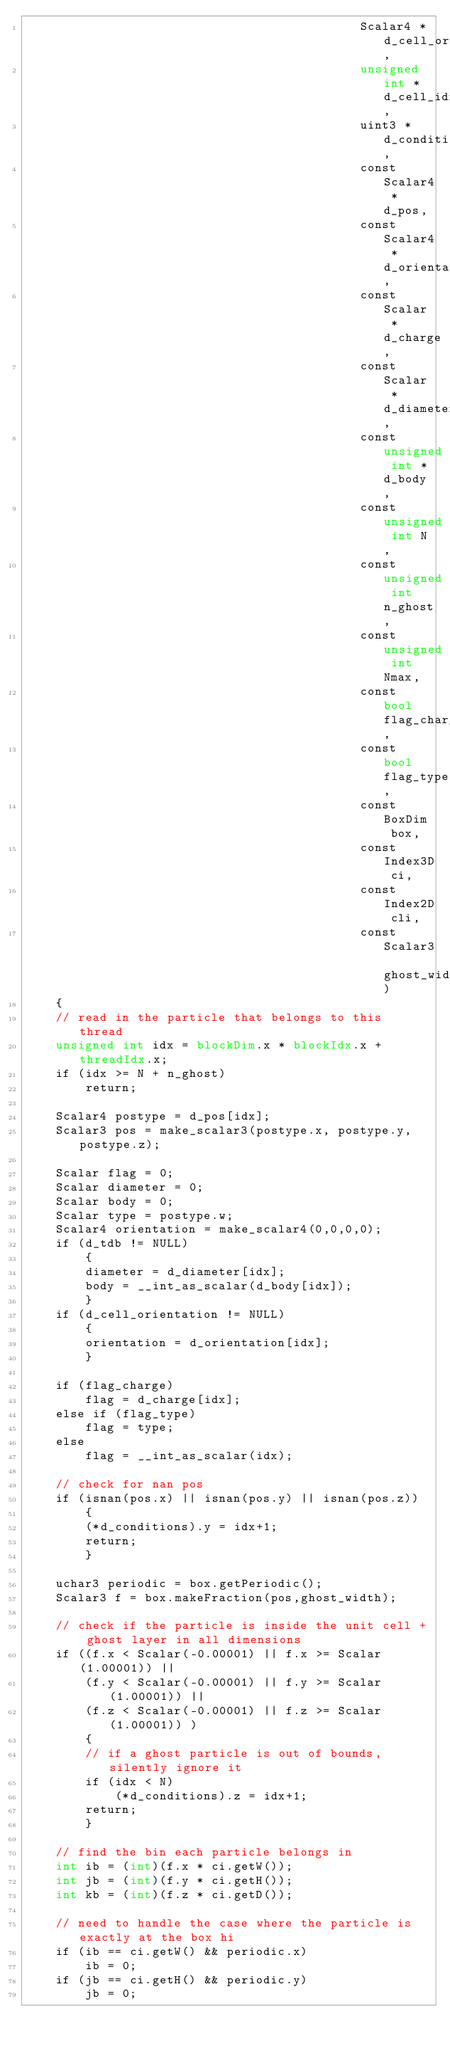Convert code to text. <code><loc_0><loc_0><loc_500><loc_500><_Cuda_>                                             Scalar4 *d_cell_orientation,
                                             unsigned int *d_cell_idx,
                                             uint3 *d_conditions,
                                             const Scalar4 *d_pos,
                                             const Scalar4 *d_orientation,
                                             const Scalar *d_charge,
                                             const Scalar *d_diameter,
                                             const unsigned int *d_body,
                                             const unsigned int N,
                                             const unsigned int n_ghost,
                                             const unsigned int Nmax,
                                             const bool flag_charge,
                                             const bool flag_type,
                                             const BoxDim box,
                                             const Index3D ci,
                                             const Index2D cli,
                                             const Scalar3 ghost_width)
    {
    // read in the particle that belongs to this thread
    unsigned int idx = blockDim.x * blockIdx.x + threadIdx.x;
    if (idx >= N + n_ghost)
        return;

    Scalar4 postype = d_pos[idx];
    Scalar3 pos = make_scalar3(postype.x, postype.y, postype.z);

    Scalar flag = 0;
    Scalar diameter = 0;
    Scalar body = 0;
    Scalar type = postype.w;
    Scalar4 orientation = make_scalar4(0,0,0,0);
    if (d_tdb != NULL)
        {
        diameter = d_diameter[idx];
        body = __int_as_scalar(d_body[idx]);
        }
    if (d_cell_orientation != NULL)
        {
        orientation = d_orientation[idx];
        }

    if (flag_charge)
        flag = d_charge[idx];
    else if (flag_type)
        flag = type;
    else
        flag = __int_as_scalar(idx);

    // check for nan pos
    if (isnan(pos.x) || isnan(pos.y) || isnan(pos.z))
        {
        (*d_conditions).y = idx+1;
        return;
        }

    uchar3 periodic = box.getPeriodic();
    Scalar3 f = box.makeFraction(pos,ghost_width);

    // check if the particle is inside the unit cell + ghost layer in all dimensions
    if ((f.x < Scalar(-0.00001) || f.x >= Scalar(1.00001)) ||
        (f.y < Scalar(-0.00001) || f.y >= Scalar(1.00001)) ||
        (f.z < Scalar(-0.00001) || f.z >= Scalar(1.00001)) )
        {
        // if a ghost particle is out of bounds, silently ignore it
        if (idx < N)
            (*d_conditions).z = idx+1;
        return;
        }

    // find the bin each particle belongs in
    int ib = (int)(f.x * ci.getW());
    int jb = (int)(f.y * ci.getH());
    int kb = (int)(f.z * ci.getD());

    // need to handle the case where the particle is exactly at the box hi
    if (ib == ci.getW() && periodic.x)
        ib = 0;
    if (jb == ci.getH() && periodic.y)
        jb = 0;</code> 